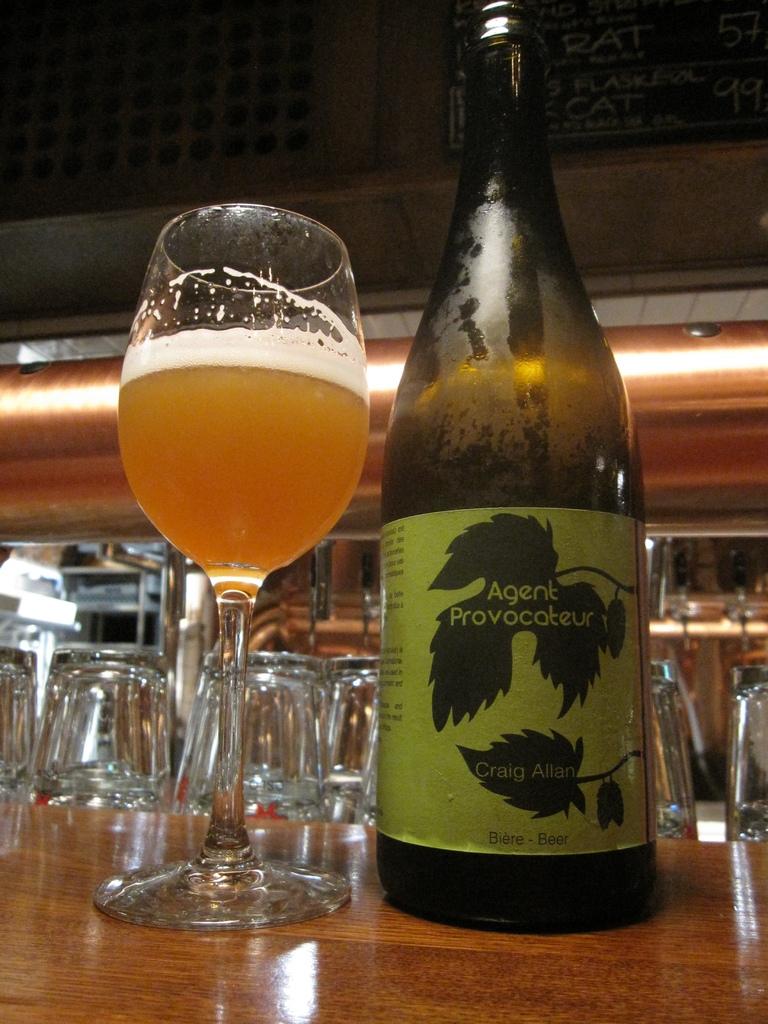What is the name of the beer?
Provide a succinct answer. Agent provocateur. 